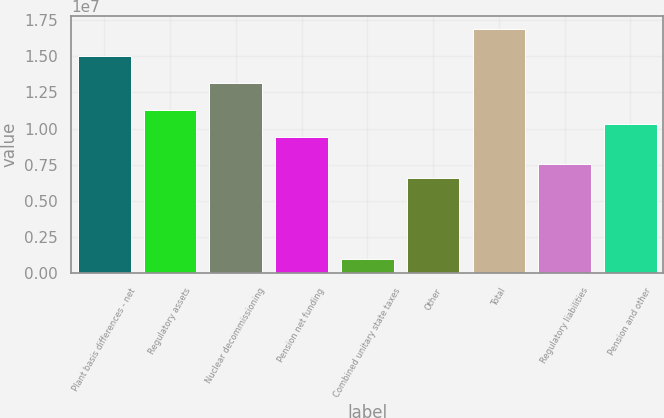Convert chart to OTSL. <chart><loc_0><loc_0><loc_500><loc_500><bar_chart><fcel>Plant basis differences - net<fcel>Regulatory assets<fcel>Nuclear decommissioning<fcel>Pension net funding<fcel>Combined unitary state taxes<fcel>Other<fcel>Total<fcel>Regulatory liabilities<fcel>Pension and other<nl><fcel>1.50339e+07<fcel>1.12801e+07<fcel>1.3157e+07<fcel>9.40312e+06<fcel>956936<fcel>6.58773e+06<fcel>1.69108e+07<fcel>7.52619e+06<fcel>1.03416e+07<nl></chart> 